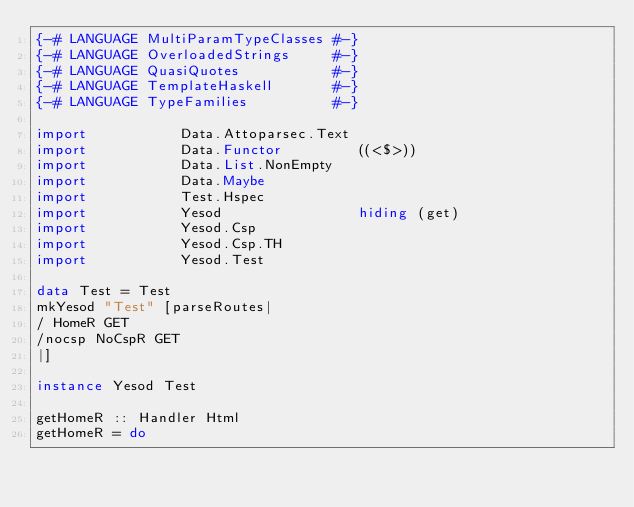<code> <loc_0><loc_0><loc_500><loc_500><_Haskell_>{-# LANGUAGE MultiParamTypeClasses #-}
{-# LANGUAGE OverloadedStrings     #-}
{-# LANGUAGE QuasiQuotes           #-}
{-# LANGUAGE TemplateHaskell       #-}
{-# LANGUAGE TypeFamilies          #-}

import           Data.Attoparsec.Text
import           Data.Functor         ((<$>))
import           Data.List.NonEmpty
import           Data.Maybe
import           Test.Hspec
import           Yesod                hiding (get)
import           Yesod.Csp
import           Yesod.Csp.TH
import           Yesod.Test

data Test = Test
mkYesod "Test" [parseRoutes|
/ HomeR GET
/nocsp NoCspR GET
|]

instance Yesod Test

getHomeR :: Handler Html
getHomeR = do</code> 